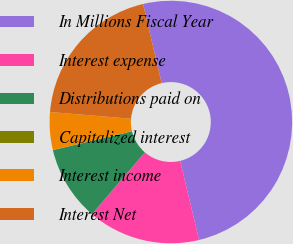Convert chart to OTSL. <chart><loc_0><loc_0><loc_500><loc_500><pie_chart><fcel>In Millions Fiscal Year<fcel>Interest expense<fcel>Distributions paid on<fcel>Capitalized interest<fcel>Interest income<fcel>Interest Net<nl><fcel>49.95%<fcel>15.0%<fcel>10.01%<fcel>0.02%<fcel>5.02%<fcel>20.0%<nl></chart> 